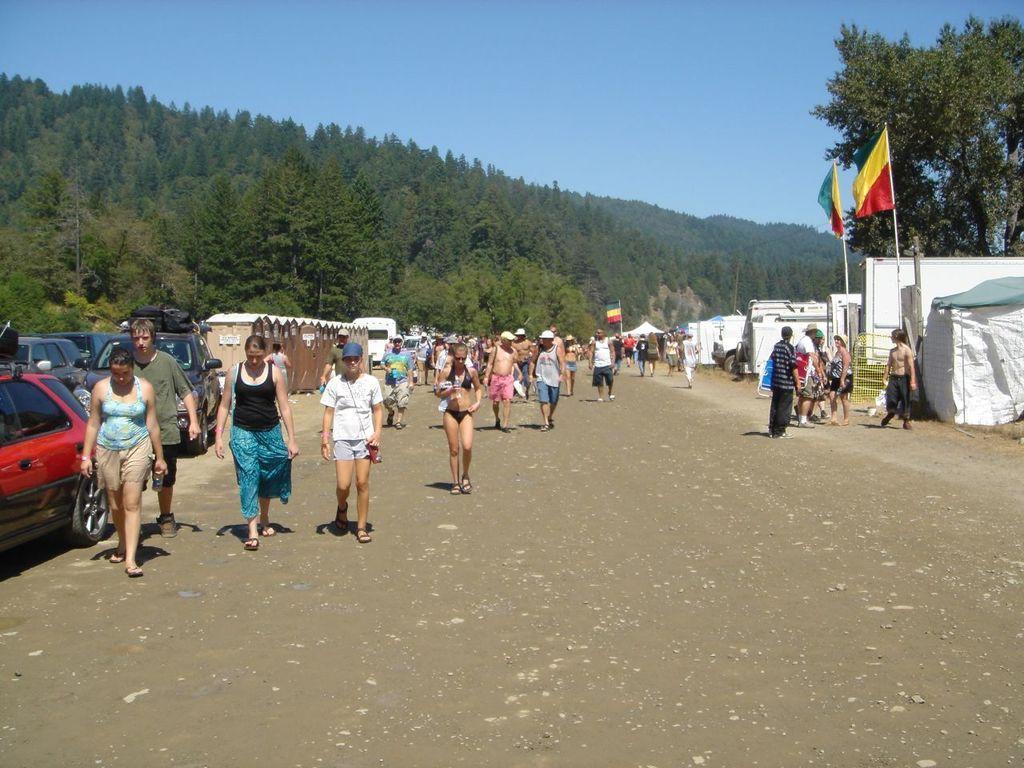In one or two sentences, can you explain what this image depicts? In this image we can see a group of people standing on the road. We can also see some vehicles parked aside, houses with roof, the flag, tent,a group of trees and the sky which looks cloudy. 